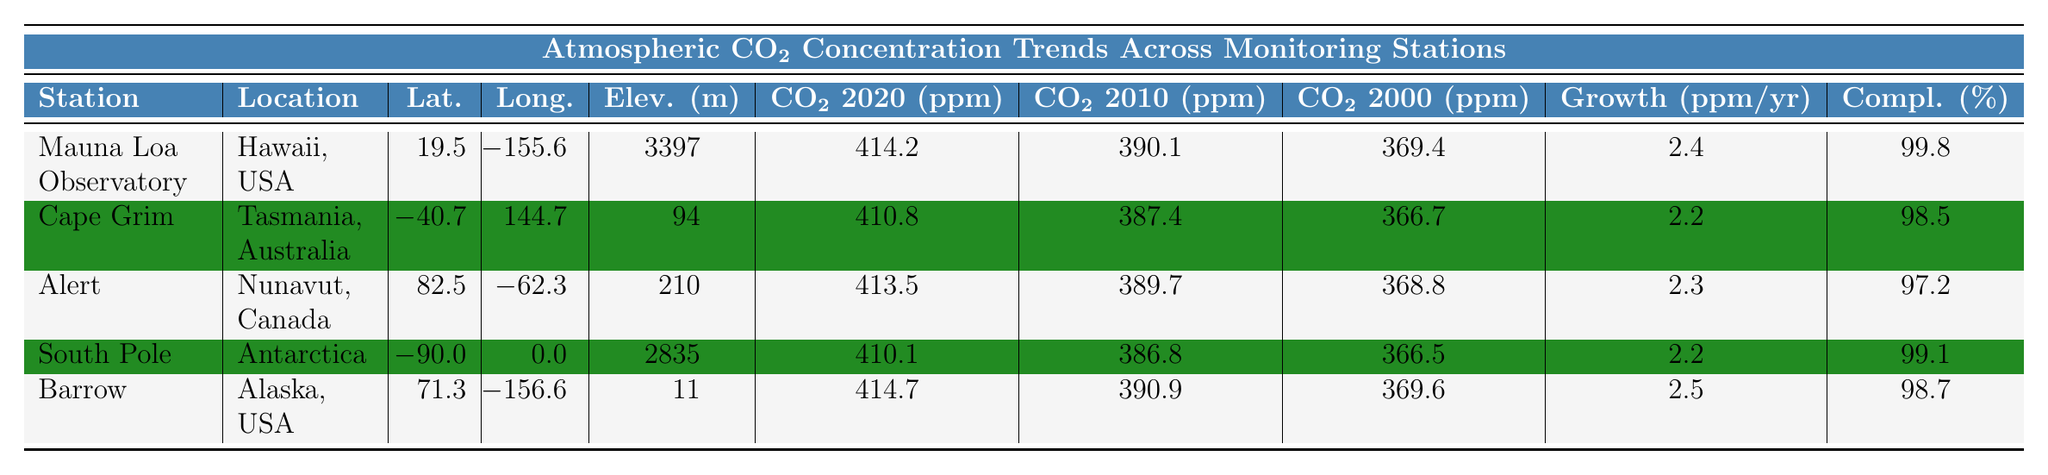What is the CO2 concentration at Mauna Loa Observatory in 2020? The table shows that the CO2 concentration at Mauna Loa Observatory in 2020 is 414.2 ppm.
Answer: 414.2 ppm Which monitoring station has the highest elevation? The table lists the elevations for each station, and South Pole has the highest elevation at 2835 m.
Answer: South Pole What is the average CO2 concentration in 2010 across all stations? The CO2 concentrations for 2010 are 390.1, 387.4, 389.7, 386.8, and 390.9 ppm. Summing these gives 1954.9, and dividing by 5 gives an average of 390.98 ppm.
Answer: 390.98 ppm Which station experienced the highest annual growth rate of CO2 concentration? The annual growth rates listed are 2.4, 2.2, 2.3, 2.2, and 2.5 ppm/year. The highest growth rate is at Barrow with 2.5 ppm/year.
Answer: Barrow Is it true that Alert has a higher CO2 concentration in 2020 than Cape Grim? The table shows Alert's concentration is 413.5 ppm, which is higher than Cape Grim's 410.8 ppm. Therefore, it is true.
Answer: Yes What is the difference in CO2 concentration between 2020 and 2000 for Barrow? The values for Barrow are 414.7 ppm in 2020 and 369.6 ppm in 2000. The difference is 414.7 - 369.6 = 45.1 ppm.
Answer: 45.1 ppm Which two stations have a data completeness percentage below 99.5%? The data completeness percentages are 99.8, 98.5, 97.2, 99.1, and 98.7 percent. Cape Grim (98.5%) and Alert (97.2%) are below 99.5%.
Answer: Cape Grim and Alert Calculate the total CO2 concentration for 2020 across all monitoring stations. The CO2 concentrations for 2020 are 414.2, 410.8, 413.5, 410.1, and 414.7 ppm. Summing these gives a total of 2073.3 ppm.
Answer: 2073.3 ppm Is there a monitoring station in Antarctica listed? The table includes South Pole as the monitoring station located in Antarctica.
Answer: Yes Which station has the lowest CO2 concentration in 2010? The values for 2010 show Cape Grim at 387.4 ppm, which is the lowest among all listed stations.
Answer: Cape Grim 